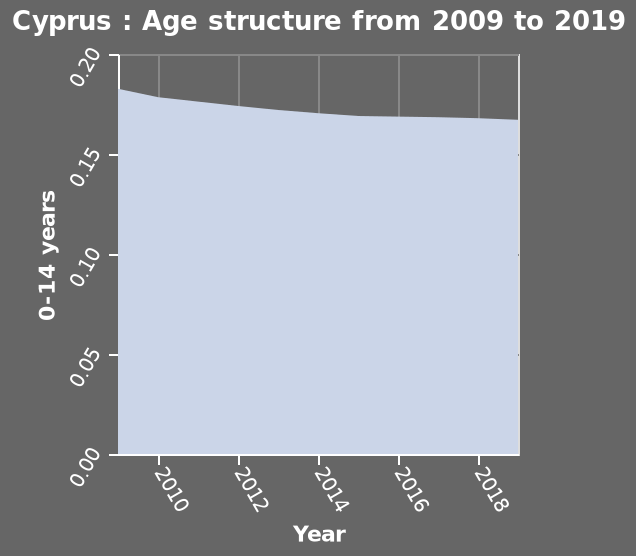<image>
Is there any change in the age structure of Cyprus between 2009 and 2019? Yes, the age structure in Cyprus has decreased slightly between 2009 to 2019. Has the age structure in Cyprus increased or decreased between 2009 and 2019? The age structure in Cyprus has decreased slightly between 2009 to 2019. please summary the statistics and relations of the chart Over the 10 years shown in the chart, age structure hasn't changed much. Age structure was highest in 2009. Age structure of 0-14 year olds declined gradually between 2009 and 2019. 